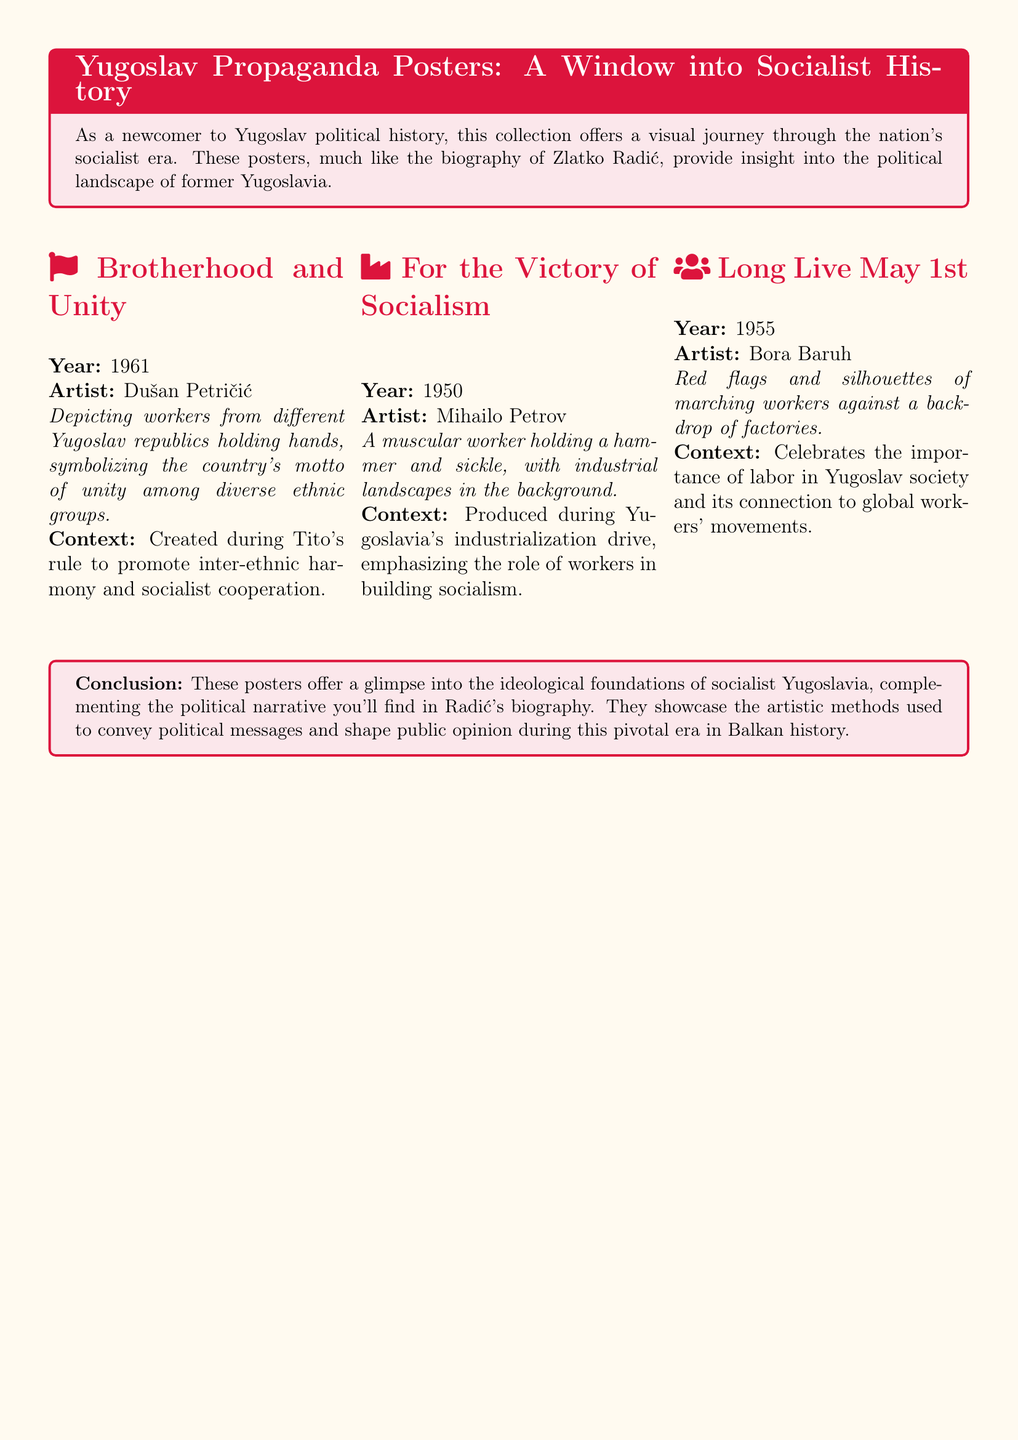What is the title of the poster from 1961? The title of the poster from 1961 is "Brotherhood and Unity," which reflects the unity among diverse ethnic groups in Yugoslavia.
Answer: Brotherhood and Unity Who is the artist of the "For the Victory of Socialism" poster? The artist of the "For the Victory of Socialism" poster is Mihailo Petrov, who created this work during the industrialization period.
Answer: Mihailo Petrov What year was the "Long Live May 1st" poster created? The "Long Live May 1st" poster was created in the year 1955, celebrating labor and workers.
Answer: 1955 What artistic element symbolizes workers in the "For the Victory of Socialism" poster? The artistic element that symbolizes workers in the "For the Victory of Socialism" poster is a muscular worker holding a hammer and sickle.
Answer: Hammer and sickle What ideological message does the poster "Brotherhood and Unity" convey? The ideological message of the "Brotherhood and Unity" poster conveys inter-ethnic harmony and socialist cooperation in Yugoslavia.
Answer: Inter-ethnic harmony What colors are primarily featured in the "Long Live May 1st" poster? The colors primarily featured in the "Long Live May 1st" poster are red, symbolizing labor and the working class.
Answer: Red During whose rule was the "Brotherhood and Unity" poster created? The "Brotherhood and Unity" poster was created during Tito's rule, promoting unity among Yugoslav republics.
Answer: Tito What does the collection of posters reflect about Yugoslav history? The collection of posters reflects the ideological foundations and political landscape of socialist Yugoslavia's history.
Answer: Ideological foundations 